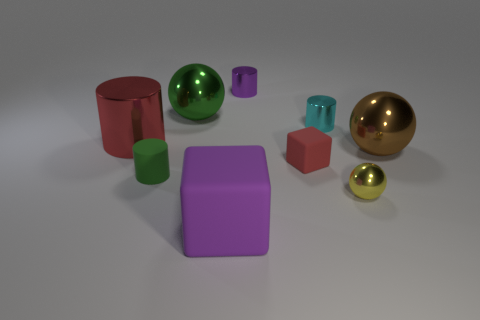Subtract 1 spheres. How many spheres are left? 2 Subtract all gray cylinders. Subtract all gray cubes. How many cylinders are left? 4 Subtract all cylinders. How many objects are left? 5 Add 9 purple metal cylinders. How many purple metal cylinders exist? 10 Subtract 0 gray cylinders. How many objects are left? 9 Subtract all small matte blocks. Subtract all tiny yellow metal balls. How many objects are left? 7 Add 1 small yellow metal spheres. How many small yellow metal spheres are left? 2 